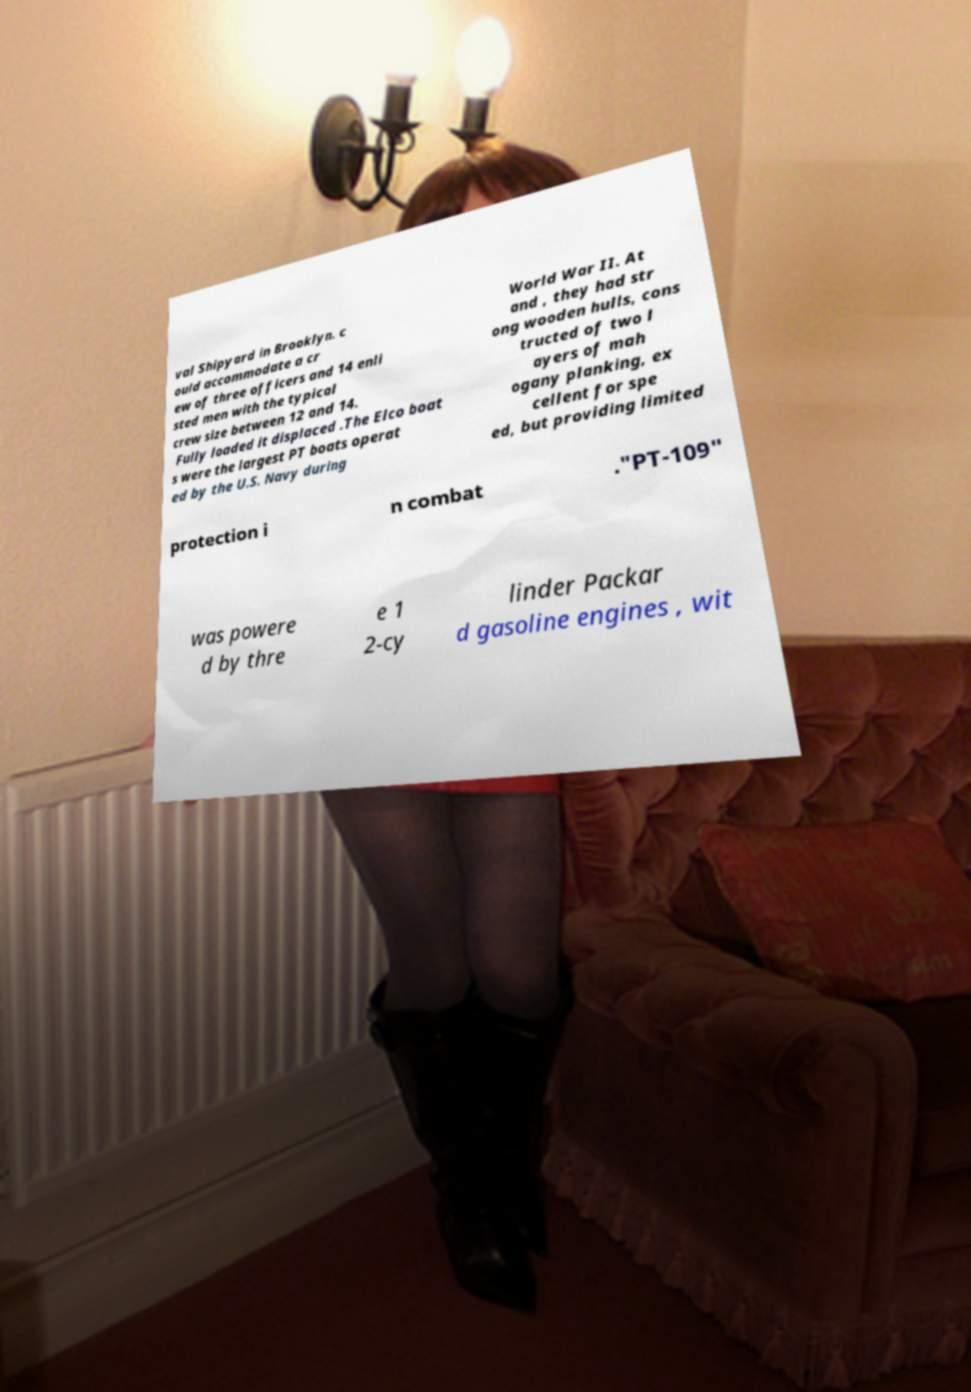Could you extract and type out the text from this image? val Shipyard in Brooklyn. c ould accommodate a cr ew of three officers and 14 enli sted men with the typical crew size between 12 and 14. Fully loaded it displaced .The Elco boat s were the largest PT boats operat ed by the U.S. Navy during World War II. At and , they had str ong wooden hulls, cons tructed of two l ayers of mah ogany planking, ex cellent for spe ed, but providing limited protection i n combat ."PT-109" was powere d by thre e 1 2-cy linder Packar d gasoline engines , wit 